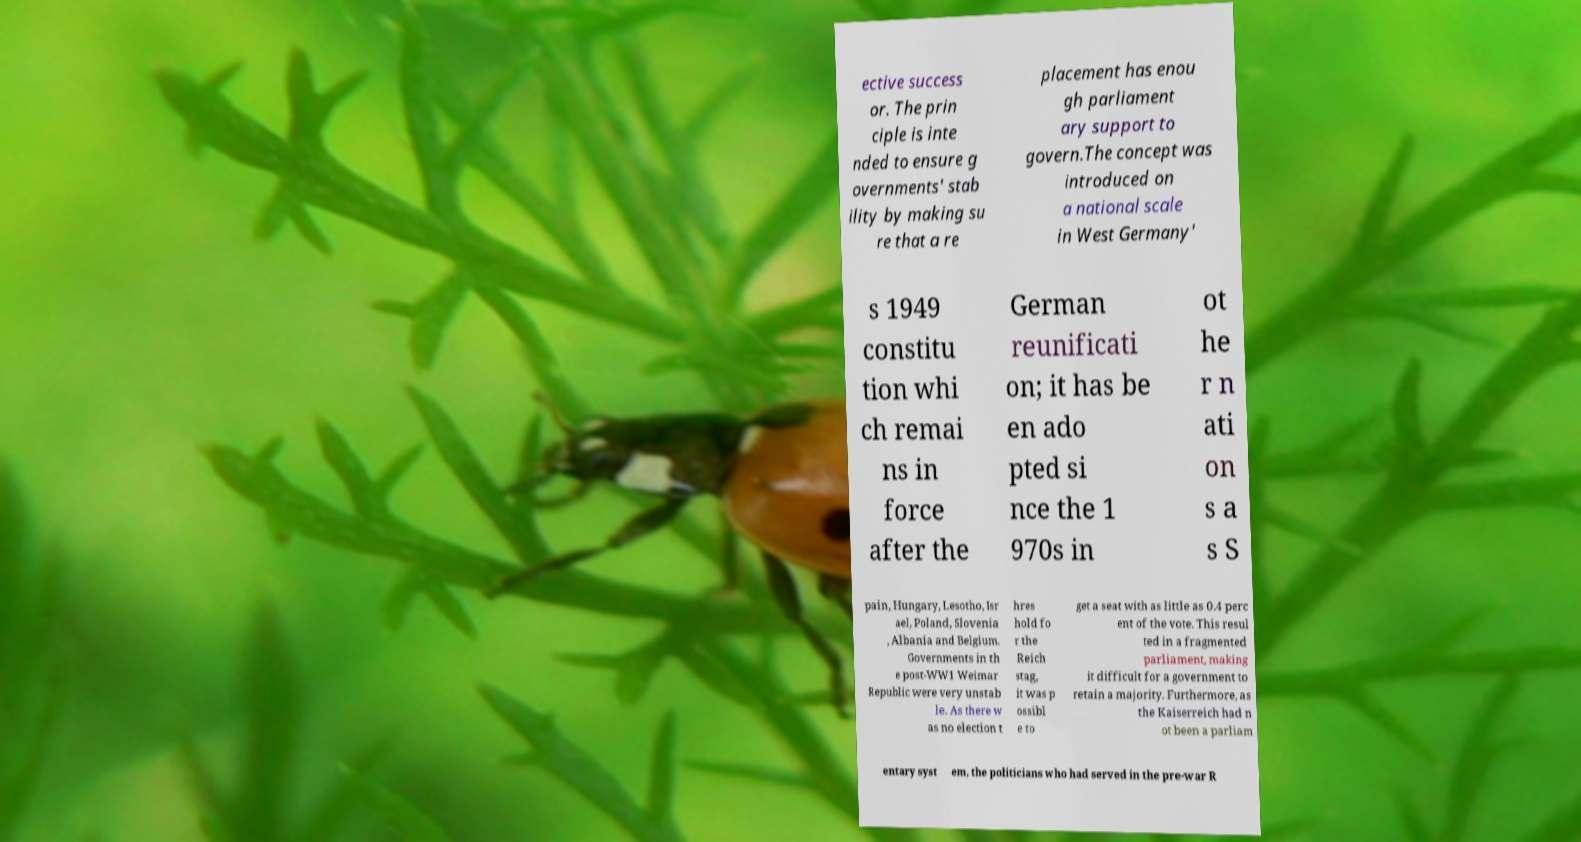Could you extract and type out the text from this image? ective success or. The prin ciple is inte nded to ensure g overnments' stab ility by making su re that a re placement has enou gh parliament ary support to govern.The concept was introduced on a national scale in West Germany' s 1949 constitu tion whi ch remai ns in force after the German reunificati on; it has be en ado pted si nce the 1 970s in ot he r n ati on s a s S pain, Hungary, Lesotho, Isr ael, Poland, Slovenia , Albania and Belgium. Governments in th e post-WW1 Weimar Republic were very unstab le. As there w as no election t hres hold fo r the Reich stag, it was p ossibl e to get a seat with as little as 0.4 perc ent of the vote. This resul ted in a fragmented parliament, making it difficult for a government to retain a majority. Furthermore, as the Kaiserreich had n ot been a parliam entary syst em, the politicians who had served in the pre-war R 